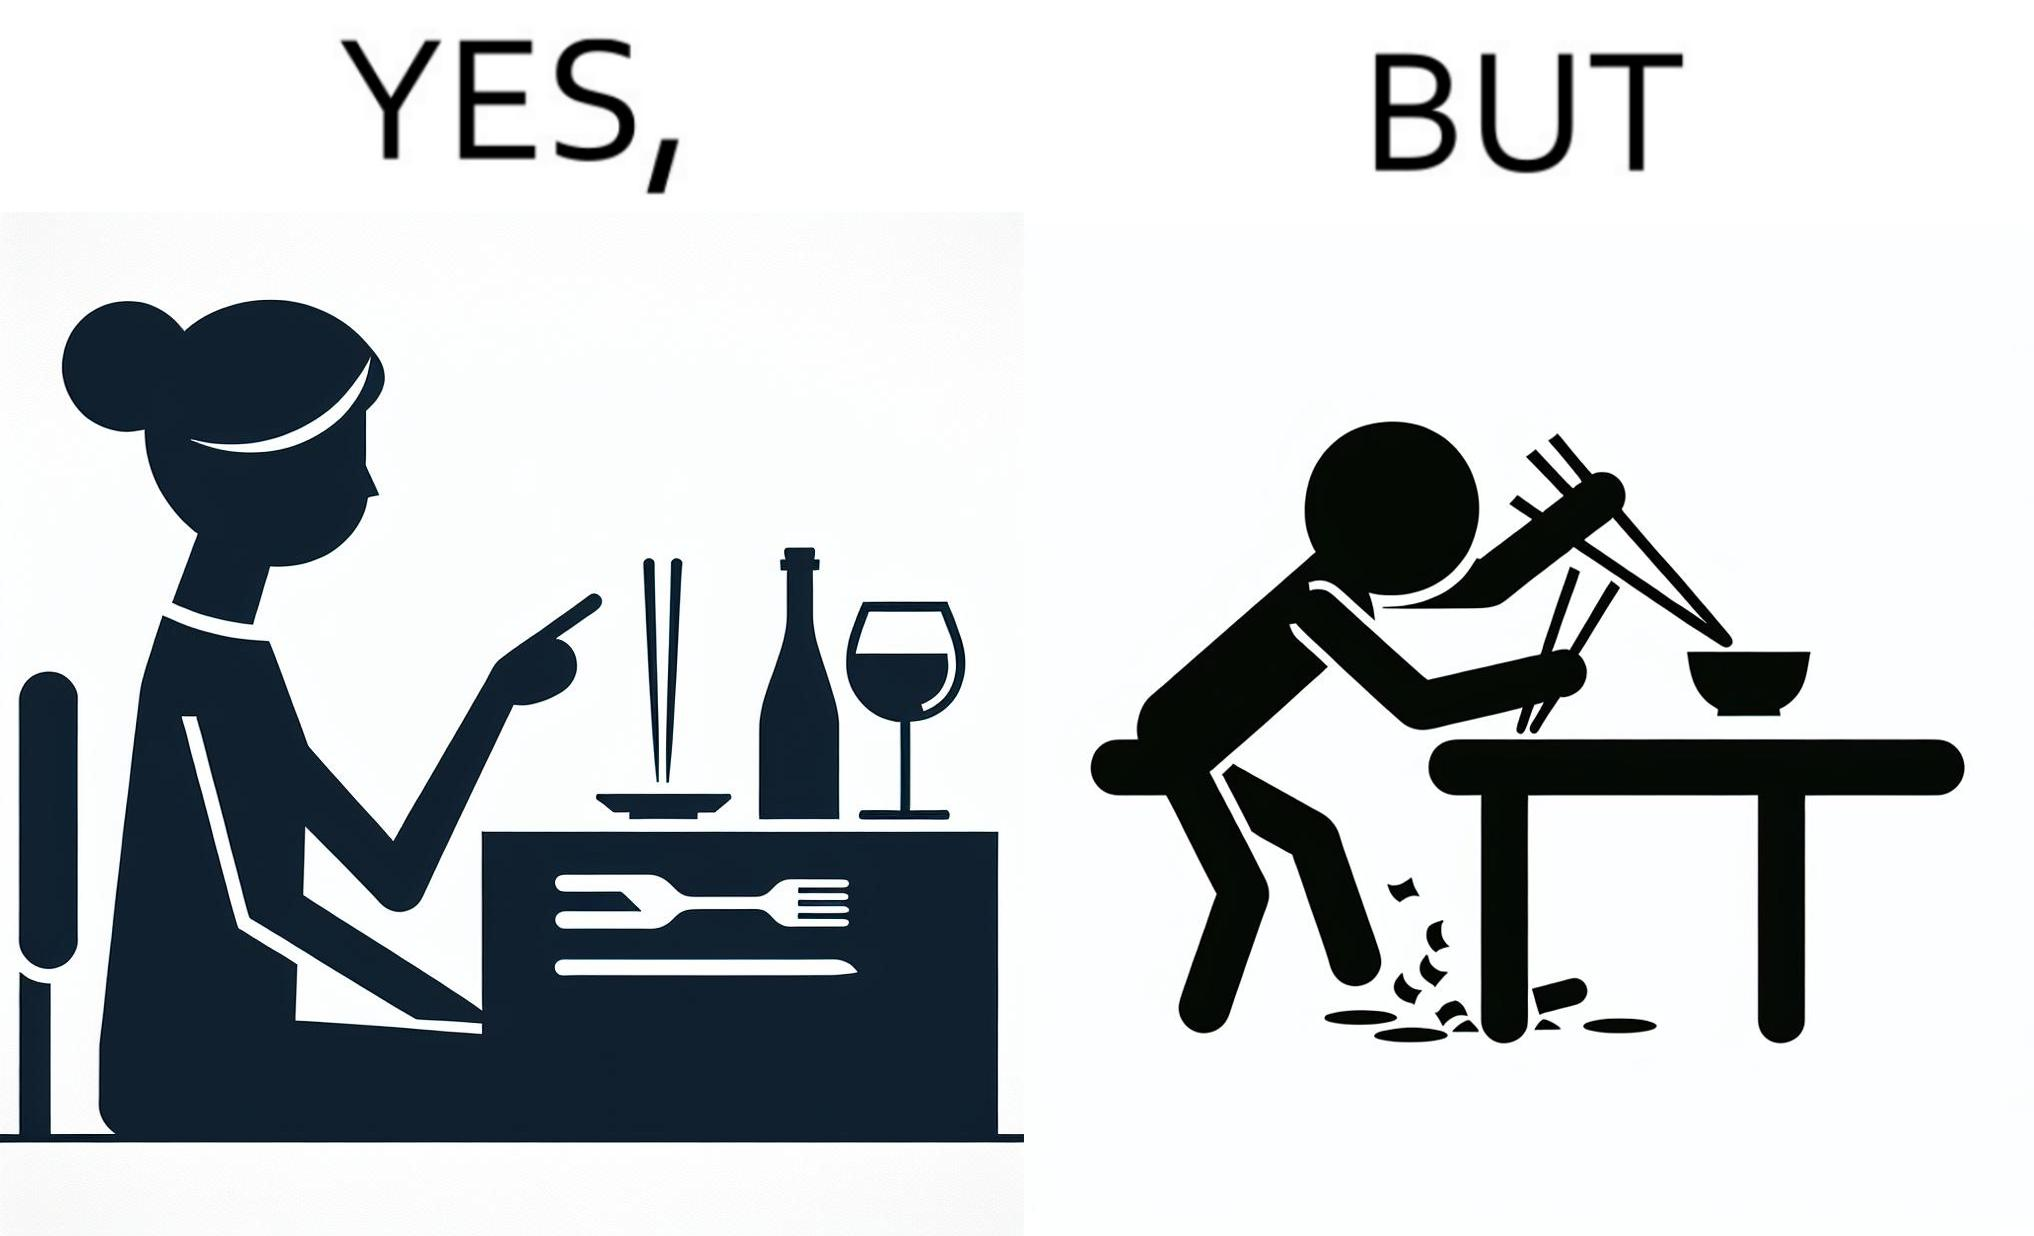Provide a description of this image. The image is satirical because even thought the woman is not able to eat food with chopstick properly, she chooses it over fork and knife to look sophisticaed. 